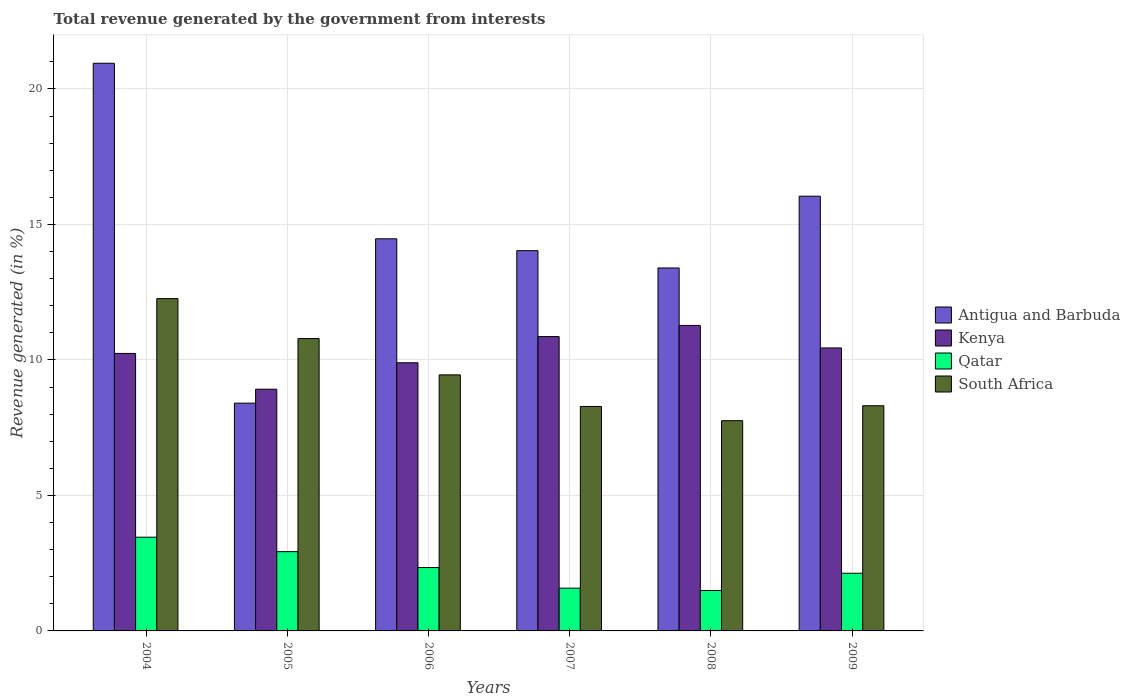What is the label of the 3rd group of bars from the left?
Your answer should be very brief. 2006. What is the total revenue generated in South Africa in 2006?
Your answer should be compact. 9.45. Across all years, what is the maximum total revenue generated in Qatar?
Your response must be concise. 3.46. Across all years, what is the minimum total revenue generated in Antigua and Barbuda?
Provide a succinct answer. 8.41. What is the total total revenue generated in Qatar in the graph?
Give a very brief answer. 13.92. What is the difference between the total revenue generated in Antigua and Barbuda in 2006 and that in 2008?
Your answer should be compact. 1.08. What is the difference between the total revenue generated in Antigua and Barbuda in 2008 and the total revenue generated in South Africa in 2009?
Your answer should be compact. 5.08. What is the average total revenue generated in Antigua and Barbuda per year?
Ensure brevity in your answer.  14.55. In the year 2005, what is the difference between the total revenue generated in Kenya and total revenue generated in South Africa?
Provide a short and direct response. -1.87. What is the ratio of the total revenue generated in Kenya in 2004 to that in 2006?
Ensure brevity in your answer.  1.03. Is the total revenue generated in Kenya in 2006 less than that in 2009?
Provide a succinct answer. Yes. What is the difference between the highest and the second highest total revenue generated in South Africa?
Your answer should be compact. 1.47. What is the difference between the highest and the lowest total revenue generated in Antigua and Barbuda?
Your response must be concise. 12.54. Is the sum of the total revenue generated in South Africa in 2006 and 2009 greater than the maximum total revenue generated in Kenya across all years?
Ensure brevity in your answer.  Yes. What does the 1st bar from the left in 2004 represents?
Your response must be concise. Antigua and Barbuda. What does the 2nd bar from the right in 2007 represents?
Your answer should be very brief. Qatar. Is it the case that in every year, the sum of the total revenue generated in Qatar and total revenue generated in Antigua and Barbuda is greater than the total revenue generated in South Africa?
Your response must be concise. Yes. How many years are there in the graph?
Offer a terse response. 6. What is the difference between two consecutive major ticks on the Y-axis?
Your answer should be compact. 5. Does the graph contain grids?
Your response must be concise. Yes. What is the title of the graph?
Ensure brevity in your answer.  Total revenue generated by the government from interests. Does "Rwanda" appear as one of the legend labels in the graph?
Keep it short and to the point. No. What is the label or title of the Y-axis?
Offer a very short reply. Revenue generated (in %). What is the Revenue generated (in %) in Antigua and Barbuda in 2004?
Your answer should be very brief. 20.95. What is the Revenue generated (in %) in Kenya in 2004?
Offer a very short reply. 10.24. What is the Revenue generated (in %) in Qatar in 2004?
Offer a very short reply. 3.46. What is the Revenue generated (in %) of South Africa in 2004?
Give a very brief answer. 12.26. What is the Revenue generated (in %) in Antigua and Barbuda in 2005?
Give a very brief answer. 8.41. What is the Revenue generated (in %) of Kenya in 2005?
Your answer should be very brief. 8.92. What is the Revenue generated (in %) in Qatar in 2005?
Give a very brief answer. 2.92. What is the Revenue generated (in %) in South Africa in 2005?
Provide a succinct answer. 10.79. What is the Revenue generated (in %) in Antigua and Barbuda in 2006?
Ensure brevity in your answer.  14.47. What is the Revenue generated (in %) of Kenya in 2006?
Offer a terse response. 9.9. What is the Revenue generated (in %) in Qatar in 2006?
Provide a short and direct response. 2.34. What is the Revenue generated (in %) of South Africa in 2006?
Provide a short and direct response. 9.45. What is the Revenue generated (in %) in Antigua and Barbuda in 2007?
Provide a succinct answer. 14.03. What is the Revenue generated (in %) in Kenya in 2007?
Your answer should be compact. 10.86. What is the Revenue generated (in %) of Qatar in 2007?
Make the answer very short. 1.58. What is the Revenue generated (in %) of South Africa in 2007?
Keep it short and to the point. 8.28. What is the Revenue generated (in %) in Antigua and Barbuda in 2008?
Provide a succinct answer. 13.39. What is the Revenue generated (in %) of Kenya in 2008?
Offer a terse response. 11.27. What is the Revenue generated (in %) of Qatar in 2008?
Keep it short and to the point. 1.49. What is the Revenue generated (in %) in South Africa in 2008?
Give a very brief answer. 7.76. What is the Revenue generated (in %) in Antigua and Barbuda in 2009?
Offer a very short reply. 16.04. What is the Revenue generated (in %) of Kenya in 2009?
Your answer should be compact. 10.44. What is the Revenue generated (in %) in Qatar in 2009?
Provide a short and direct response. 2.13. What is the Revenue generated (in %) in South Africa in 2009?
Offer a very short reply. 8.31. Across all years, what is the maximum Revenue generated (in %) in Antigua and Barbuda?
Your answer should be compact. 20.95. Across all years, what is the maximum Revenue generated (in %) of Kenya?
Provide a succinct answer. 11.27. Across all years, what is the maximum Revenue generated (in %) of Qatar?
Offer a very short reply. 3.46. Across all years, what is the maximum Revenue generated (in %) of South Africa?
Make the answer very short. 12.26. Across all years, what is the minimum Revenue generated (in %) of Antigua and Barbuda?
Your answer should be very brief. 8.41. Across all years, what is the minimum Revenue generated (in %) in Kenya?
Your answer should be compact. 8.92. Across all years, what is the minimum Revenue generated (in %) of Qatar?
Ensure brevity in your answer.  1.49. Across all years, what is the minimum Revenue generated (in %) in South Africa?
Your answer should be compact. 7.76. What is the total Revenue generated (in %) of Antigua and Barbuda in the graph?
Your answer should be very brief. 87.29. What is the total Revenue generated (in %) in Kenya in the graph?
Ensure brevity in your answer.  61.63. What is the total Revenue generated (in %) of Qatar in the graph?
Offer a very short reply. 13.92. What is the total Revenue generated (in %) in South Africa in the graph?
Offer a very short reply. 56.85. What is the difference between the Revenue generated (in %) of Antigua and Barbuda in 2004 and that in 2005?
Offer a very short reply. 12.54. What is the difference between the Revenue generated (in %) in Kenya in 2004 and that in 2005?
Offer a very short reply. 1.32. What is the difference between the Revenue generated (in %) in Qatar in 2004 and that in 2005?
Offer a terse response. 0.53. What is the difference between the Revenue generated (in %) of South Africa in 2004 and that in 2005?
Ensure brevity in your answer.  1.47. What is the difference between the Revenue generated (in %) in Antigua and Barbuda in 2004 and that in 2006?
Make the answer very short. 6.48. What is the difference between the Revenue generated (in %) in Kenya in 2004 and that in 2006?
Keep it short and to the point. 0.34. What is the difference between the Revenue generated (in %) of Qatar in 2004 and that in 2006?
Your answer should be compact. 1.12. What is the difference between the Revenue generated (in %) in South Africa in 2004 and that in 2006?
Your response must be concise. 2.81. What is the difference between the Revenue generated (in %) in Antigua and Barbuda in 2004 and that in 2007?
Keep it short and to the point. 6.92. What is the difference between the Revenue generated (in %) in Kenya in 2004 and that in 2007?
Keep it short and to the point. -0.62. What is the difference between the Revenue generated (in %) of Qatar in 2004 and that in 2007?
Provide a short and direct response. 1.88. What is the difference between the Revenue generated (in %) of South Africa in 2004 and that in 2007?
Your response must be concise. 3.98. What is the difference between the Revenue generated (in %) in Antigua and Barbuda in 2004 and that in 2008?
Keep it short and to the point. 7.55. What is the difference between the Revenue generated (in %) of Kenya in 2004 and that in 2008?
Offer a very short reply. -1.03. What is the difference between the Revenue generated (in %) of Qatar in 2004 and that in 2008?
Your answer should be very brief. 1.97. What is the difference between the Revenue generated (in %) of South Africa in 2004 and that in 2008?
Your response must be concise. 4.51. What is the difference between the Revenue generated (in %) in Antigua and Barbuda in 2004 and that in 2009?
Keep it short and to the point. 4.91. What is the difference between the Revenue generated (in %) of Kenya in 2004 and that in 2009?
Make the answer very short. -0.2. What is the difference between the Revenue generated (in %) in Qatar in 2004 and that in 2009?
Provide a short and direct response. 1.33. What is the difference between the Revenue generated (in %) in South Africa in 2004 and that in 2009?
Give a very brief answer. 3.95. What is the difference between the Revenue generated (in %) of Antigua and Barbuda in 2005 and that in 2006?
Offer a very short reply. -6.07. What is the difference between the Revenue generated (in %) in Kenya in 2005 and that in 2006?
Offer a very short reply. -0.98. What is the difference between the Revenue generated (in %) in Qatar in 2005 and that in 2006?
Offer a terse response. 0.59. What is the difference between the Revenue generated (in %) of South Africa in 2005 and that in 2006?
Ensure brevity in your answer.  1.34. What is the difference between the Revenue generated (in %) of Antigua and Barbuda in 2005 and that in 2007?
Your answer should be very brief. -5.63. What is the difference between the Revenue generated (in %) of Kenya in 2005 and that in 2007?
Provide a short and direct response. -1.94. What is the difference between the Revenue generated (in %) of Qatar in 2005 and that in 2007?
Ensure brevity in your answer.  1.35. What is the difference between the Revenue generated (in %) in South Africa in 2005 and that in 2007?
Your answer should be compact. 2.51. What is the difference between the Revenue generated (in %) of Antigua and Barbuda in 2005 and that in 2008?
Provide a short and direct response. -4.99. What is the difference between the Revenue generated (in %) in Kenya in 2005 and that in 2008?
Make the answer very short. -2.35. What is the difference between the Revenue generated (in %) in Qatar in 2005 and that in 2008?
Your response must be concise. 1.43. What is the difference between the Revenue generated (in %) of South Africa in 2005 and that in 2008?
Ensure brevity in your answer.  3.03. What is the difference between the Revenue generated (in %) in Antigua and Barbuda in 2005 and that in 2009?
Provide a short and direct response. -7.64. What is the difference between the Revenue generated (in %) in Kenya in 2005 and that in 2009?
Provide a succinct answer. -1.52. What is the difference between the Revenue generated (in %) of Qatar in 2005 and that in 2009?
Make the answer very short. 0.8. What is the difference between the Revenue generated (in %) in South Africa in 2005 and that in 2009?
Provide a short and direct response. 2.48. What is the difference between the Revenue generated (in %) in Antigua and Barbuda in 2006 and that in 2007?
Offer a very short reply. 0.44. What is the difference between the Revenue generated (in %) in Kenya in 2006 and that in 2007?
Give a very brief answer. -0.97. What is the difference between the Revenue generated (in %) of Qatar in 2006 and that in 2007?
Offer a very short reply. 0.76. What is the difference between the Revenue generated (in %) of South Africa in 2006 and that in 2007?
Your answer should be very brief. 1.17. What is the difference between the Revenue generated (in %) in Kenya in 2006 and that in 2008?
Provide a succinct answer. -1.38. What is the difference between the Revenue generated (in %) of Qatar in 2006 and that in 2008?
Provide a short and direct response. 0.85. What is the difference between the Revenue generated (in %) of South Africa in 2006 and that in 2008?
Keep it short and to the point. 1.69. What is the difference between the Revenue generated (in %) of Antigua and Barbuda in 2006 and that in 2009?
Your response must be concise. -1.57. What is the difference between the Revenue generated (in %) of Kenya in 2006 and that in 2009?
Provide a short and direct response. -0.55. What is the difference between the Revenue generated (in %) of Qatar in 2006 and that in 2009?
Ensure brevity in your answer.  0.21. What is the difference between the Revenue generated (in %) in South Africa in 2006 and that in 2009?
Your answer should be very brief. 1.14. What is the difference between the Revenue generated (in %) of Antigua and Barbuda in 2007 and that in 2008?
Make the answer very short. 0.64. What is the difference between the Revenue generated (in %) in Kenya in 2007 and that in 2008?
Give a very brief answer. -0.41. What is the difference between the Revenue generated (in %) in Qatar in 2007 and that in 2008?
Make the answer very short. 0.09. What is the difference between the Revenue generated (in %) in South Africa in 2007 and that in 2008?
Your response must be concise. 0.52. What is the difference between the Revenue generated (in %) in Antigua and Barbuda in 2007 and that in 2009?
Provide a short and direct response. -2.01. What is the difference between the Revenue generated (in %) of Kenya in 2007 and that in 2009?
Make the answer very short. 0.42. What is the difference between the Revenue generated (in %) in Qatar in 2007 and that in 2009?
Keep it short and to the point. -0.55. What is the difference between the Revenue generated (in %) of South Africa in 2007 and that in 2009?
Your response must be concise. -0.03. What is the difference between the Revenue generated (in %) in Antigua and Barbuda in 2008 and that in 2009?
Give a very brief answer. -2.65. What is the difference between the Revenue generated (in %) in Kenya in 2008 and that in 2009?
Give a very brief answer. 0.83. What is the difference between the Revenue generated (in %) of Qatar in 2008 and that in 2009?
Your response must be concise. -0.64. What is the difference between the Revenue generated (in %) in South Africa in 2008 and that in 2009?
Provide a succinct answer. -0.55. What is the difference between the Revenue generated (in %) in Antigua and Barbuda in 2004 and the Revenue generated (in %) in Kenya in 2005?
Your response must be concise. 12.03. What is the difference between the Revenue generated (in %) of Antigua and Barbuda in 2004 and the Revenue generated (in %) of Qatar in 2005?
Ensure brevity in your answer.  18.02. What is the difference between the Revenue generated (in %) in Antigua and Barbuda in 2004 and the Revenue generated (in %) in South Africa in 2005?
Provide a short and direct response. 10.16. What is the difference between the Revenue generated (in %) in Kenya in 2004 and the Revenue generated (in %) in Qatar in 2005?
Provide a short and direct response. 7.32. What is the difference between the Revenue generated (in %) of Kenya in 2004 and the Revenue generated (in %) of South Africa in 2005?
Provide a succinct answer. -0.55. What is the difference between the Revenue generated (in %) of Qatar in 2004 and the Revenue generated (in %) of South Africa in 2005?
Ensure brevity in your answer.  -7.33. What is the difference between the Revenue generated (in %) in Antigua and Barbuda in 2004 and the Revenue generated (in %) in Kenya in 2006?
Offer a terse response. 11.05. What is the difference between the Revenue generated (in %) of Antigua and Barbuda in 2004 and the Revenue generated (in %) of Qatar in 2006?
Offer a very short reply. 18.61. What is the difference between the Revenue generated (in %) of Antigua and Barbuda in 2004 and the Revenue generated (in %) of South Africa in 2006?
Your answer should be very brief. 11.5. What is the difference between the Revenue generated (in %) in Kenya in 2004 and the Revenue generated (in %) in Qatar in 2006?
Provide a short and direct response. 7.9. What is the difference between the Revenue generated (in %) in Kenya in 2004 and the Revenue generated (in %) in South Africa in 2006?
Provide a short and direct response. 0.79. What is the difference between the Revenue generated (in %) of Qatar in 2004 and the Revenue generated (in %) of South Africa in 2006?
Your answer should be compact. -5.99. What is the difference between the Revenue generated (in %) of Antigua and Barbuda in 2004 and the Revenue generated (in %) of Kenya in 2007?
Your answer should be compact. 10.09. What is the difference between the Revenue generated (in %) of Antigua and Barbuda in 2004 and the Revenue generated (in %) of Qatar in 2007?
Provide a short and direct response. 19.37. What is the difference between the Revenue generated (in %) in Antigua and Barbuda in 2004 and the Revenue generated (in %) in South Africa in 2007?
Keep it short and to the point. 12.67. What is the difference between the Revenue generated (in %) of Kenya in 2004 and the Revenue generated (in %) of Qatar in 2007?
Provide a short and direct response. 8.66. What is the difference between the Revenue generated (in %) in Kenya in 2004 and the Revenue generated (in %) in South Africa in 2007?
Make the answer very short. 1.96. What is the difference between the Revenue generated (in %) of Qatar in 2004 and the Revenue generated (in %) of South Africa in 2007?
Your answer should be compact. -4.82. What is the difference between the Revenue generated (in %) of Antigua and Barbuda in 2004 and the Revenue generated (in %) of Kenya in 2008?
Give a very brief answer. 9.67. What is the difference between the Revenue generated (in %) of Antigua and Barbuda in 2004 and the Revenue generated (in %) of Qatar in 2008?
Provide a succinct answer. 19.46. What is the difference between the Revenue generated (in %) in Antigua and Barbuda in 2004 and the Revenue generated (in %) in South Africa in 2008?
Offer a terse response. 13.19. What is the difference between the Revenue generated (in %) in Kenya in 2004 and the Revenue generated (in %) in Qatar in 2008?
Make the answer very short. 8.75. What is the difference between the Revenue generated (in %) in Kenya in 2004 and the Revenue generated (in %) in South Africa in 2008?
Offer a terse response. 2.48. What is the difference between the Revenue generated (in %) in Qatar in 2004 and the Revenue generated (in %) in South Africa in 2008?
Offer a terse response. -4.3. What is the difference between the Revenue generated (in %) of Antigua and Barbuda in 2004 and the Revenue generated (in %) of Kenya in 2009?
Your response must be concise. 10.51. What is the difference between the Revenue generated (in %) in Antigua and Barbuda in 2004 and the Revenue generated (in %) in Qatar in 2009?
Provide a succinct answer. 18.82. What is the difference between the Revenue generated (in %) of Antigua and Barbuda in 2004 and the Revenue generated (in %) of South Africa in 2009?
Make the answer very short. 12.64. What is the difference between the Revenue generated (in %) of Kenya in 2004 and the Revenue generated (in %) of Qatar in 2009?
Make the answer very short. 8.11. What is the difference between the Revenue generated (in %) in Kenya in 2004 and the Revenue generated (in %) in South Africa in 2009?
Offer a terse response. 1.93. What is the difference between the Revenue generated (in %) in Qatar in 2004 and the Revenue generated (in %) in South Africa in 2009?
Provide a succinct answer. -4.85. What is the difference between the Revenue generated (in %) in Antigua and Barbuda in 2005 and the Revenue generated (in %) in Kenya in 2006?
Provide a short and direct response. -1.49. What is the difference between the Revenue generated (in %) in Antigua and Barbuda in 2005 and the Revenue generated (in %) in Qatar in 2006?
Offer a very short reply. 6.07. What is the difference between the Revenue generated (in %) of Antigua and Barbuda in 2005 and the Revenue generated (in %) of South Africa in 2006?
Give a very brief answer. -1.04. What is the difference between the Revenue generated (in %) of Kenya in 2005 and the Revenue generated (in %) of Qatar in 2006?
Your response must be concise. 6.58. What is the difference between the Revenue generated (in %) in Kenya in 2005 and the Revenue generated (in %) in South Africa in 2006?
Provide a succinct answer. -0.53. What is the difference between the Revenue generated (in %) in Qatar in 2005 and the Revenue generated (in %) in South Africa in 2006?
Offer a terse response. -6.52. What is the difference between the Revenue generated (in %) in Antigua and Barbuda in 2005 and the Revenue generated (in %) in Kenya in 2007?
Provide a short and direct response. -2.46. What is the difference between the Revenue generated (in %) of Antigua and Barbuda in 2005 and the Revenue generated (in %) of Qatar in 2007?
Provide a succinct answer. 6.83. What is the difference between the Revenue generated (in %) of Antigua and Barbuda in 2005 and the Revenue generated (in %) of South Africa in 2007?
Provide a short and direct response. 0.12. What is the difference between the Revenue generated (in %) in Kenya in 2005 and the Revenue generated (in %) in Qatar in 2007?
Offer a very short reply. 7.34. What is the difference between the Revenue generated (in %) of Kenya in 2005 and the Revenue generated (in %) of South Africa in 2007?
Keep it short and to the point. 0.64. What is the difference between the Revenue generated (in %) in Qatar in 2005 and the Revenue generated (in %) in South Africa in 2007?
Provide a succinct answer. -5.36. What is the difference between the Revenue generated (in %) of Antigua and Barbuda in 2005 and the Revenue generated (in %) of Kenya in 2008?
Offer a very short reply. -2.87. What is the difference between the Revenue generated (in %) in Antigua and Barbuda in 2005 and the Revenue generated (in %) in Qatar in 2008?
Provide a succinct answer. 6.91. What is the difference between the Revenue generated (in %) in Antigua and Barbuda in 2005 and the Revenue generated (in %) in South Africa in 2008?
Your answer should be compact. 0.65. What is the difference between the Revenue generated (in %) of Kenya in 2005 and the Revenue generated (in %) of Qatar in 2008?
Keep it short and to the point. 7.43. What is the difference between the Revenue generated (in %) of Kenya in 2005 and the Revenue generated (in %) of South Africa in 2008?
Offer a terse response. 1.16. What is the difference between the Revenue generated (in %) in Qatar in 2005 and the Revenue generated (in %) in South Africa in 2008?
Ensure brevity in your answer.  -4.83. What is the difference between the Revenue generated (in %) of Antigua and Barbuda in 2005 and the Revenue generated (in %) of Kenya in 2009?
Give a very brief answer. -2.04. What is the difference between the Revenue generated (in %) of Antigua and Barbuda in 2005 and the Revenue generated (in %) of Qatar in 2009?
Offer a very short reply. 6.28. What is the difference between the Revenue generated (in %) in Antigua and Barbuda in 2005 and the Revenue generated (in %) in South Africa in 2009?
Make the answer very short. 0.1. What is the difference between the Revenue generated (in %) of Kenya in 2005 and the Revenue generated (in %) of Qatar in 2009?
Your answer should be very brief. 6.79. What is the difference between the Revenue generated (in %) of Kenya in 2005 and the Revenue generated (in %) of South Africa in 2009?
Keep it short and to the point. 0.61. What is the difference between the Revenue generated (in %) of Qatar in 2005 and the Revenue generated (in %) of South Africa in 2009?
Offer a very short reply. -5.38. What is the difference between the Revenue generated (in %) in Antigua and Barbuda in 2006 and the Revenue generated (in %) in Kenya in 2007?
Keep it short and to the point. 3.61. What is the difference between the Revenue generated (in %) of Antigua and Barbuda in 2006 and the Revenue generated (in %) of Qatar in 2007?
Your response must be concise. 12.89. What is the difference between the Revenue generated (in %) in Antigua and Barbuda in 2006 and the Revenue generated (in %) in South Africa in 2007?
Ensure brevity in your answer.  6.19. What is the difference between the Revenue generated (in %) in Kenya in 2006 and the Revenue generated (in %) in Qatar in 2007?
Keep it short and to the point. 8.32. What is the difference between the Revenue generated (in %) of Kenya in 2006 and the Revenue generated (in %) of South Africa in 2007?
Your answer should be compact. 1.61. What is the difference between the Revenue generated (in %) in Qatar in 2006 and the Revenue generated (in %) in South Africa in 2007?
Keep it short and to the point. -5.94. What is the difference between the Revenue generated (in %) in Antigua and Barbuda in 2006 and the Revenue generated (in %) in Kenya in 2008?
Provide a succinct answer. 3.2. What is the difference between the Revenue generated (in %) in Antigua and Barbuda in 2006 and the Revenue generated (in %) in Qatar in 2008?
Keep it short and to the point. 12.98. What is the difference between the Revenue generated (in %) in Antigua and Barbuda in 2006 and the Revenue generated (in %) in South Africa in 2008?
Offer a terse response. 6.71. What is the difference between the Revenue generated (in %) in Kenya in 2006 and the Revenue generated (in %) in Qatar in 2008?
Your response must be concise. 8.4. What is the difference between the Revenue generated (in %) in Kenya in 2006 and the Revenue generated (in %) in South Africa in 2008?
Your answer should be compact. 2.14. What is the difference between the Revenue generated (in %) of Qatar in 2006 and the Revenue generated (in %) of South Africa in 2008?
Offer a terse response. -5.42. What is the difference between the Revenue generated (in %) in Antigua and Barbuda in 2006 and the Revenue generated (in %) in Kenya in 2009?
Keep it short and to the point. 4.03. What is the difference between the Revenue generated (in %) in Antigua and Barbuda in 2006 and the Revenue generated (in %) in Qatar in 2009?
Offer a terse response. 12.34. What is the difference between the Revenue generated (in %) of Antigua and Barbuda in 2006 and the Revenue generated (in %) of South Africa in 2009?
Your answer should be very brief. 6.16. What is the difference between the Revenue generated (in %) in Kenya in 2006 and the Revenue generated (in %) in Qatar in 2009?
Offer a very short reply. 7.77. What is the difference between the Revenue generated (in %) in Kenya in 2006 and the Revenue generated (in %) in South Africa in 2009?
Keep it short and to the point. 1.59. What is the difference between the Revenue generated (in %) of Qatar in 2006 and the Revenue generated (in %) of South Africa in 2009?
Give a very brief answer. -5.97. What is the difference between the Revenue generated (in %) of Antigua and Barbuda in 2007 and the Revenue generated (in %) of Kenya in 2008?
Provide a succinct answer. 2.76. What is the difference between the Revenue generated (in %) of Antigua and Barbuda in 2007 and the Revenue generated (in %) of Qatar in 2008?
Provide a short and direct response. 12.54. What is the difference between the Revenue generated (in %) of Antigua and Barbuda in 2007 and the Revenue generated (in %) of South Africa in 2008?
Your answer should be very brief. 6.27. What is the difference between the Revenue generated (in %) of Kenya in 2007 and the Revenue generated (in %) of Qatar in 2008?
Ensure brevity in your answer.  9.37. What is the difference between the Revenue generated (in %) in Kenya in 2007 and the Revenue generated (in %) in South Africa in 2008?
Make the answer very short. 3.1. What is the difference between the Revenue generated (in %) in Qatar in 2007 and the Revenue generated (in %) in South Africa in 2008?
Your answer should be very brief. -6.18. What is the difference between the Revenue generated (in %) in Antigua and Barbuda in 2007 and the Revenue generated (in %) in Kenya in 2009?
Make the answer very short. 3.59. What is the difference between the Revenue generated (in %) in Antigua and Barbuda in 2007 and the Revenue generated (in %) in Qatar in 2009?
Your answer should be compact. 11.9. What is the difference between the Revenue generated (in %) of Antigua and Barbuda in 2007 and the Revenue generated (in %) of South Africa in 2009?
Your response must be concise. 5.72. What is the difference between the Revenue generated (in %) of Kenya in 2007 and the Revenue generated (in %) of Qatar in 2009?
Offer a terse response. 8.73. What is the difference between the Revenue generated (in %) in Kenya in 2007 and the Revenue generated (in %) in South Africa in 2009?
Make the answer very short. 2.55. What is the difference between the Revenue generated (in %) of Qatar in 2007 and the Revenue generated (in %) of South Africa in 2009?
Your answer should be very brief. -6.73. What is the difference between the Revenue generated (in %) of Antigua and Barbuda in 2008 and the Revenue generated (in %) of Kenya in 2009?
Ensure brevity in your answer.  2.95. What is the difference between the Revenue generated (in %) of Antigua and Barbuda in 2008 and the Revenue generated (in %) of Qatar in 2009?
Offer a terse response. 11.27. What is the difference between the Revenue generated (in %) of Antigua and Barbuda in 2008 and the Revenue generated (in %) of South Africa in 2009?
Offer a very short reply. 5.08. What is the difference between the Revenue generated (in %) of Kenya in 2008 and the Revenue generated (in %) of Qatar in 2009?
Your response must be concise. 9.15. What is the difference between the Revenue generated (in %) in Kenya in 2008 and the Revenue generated (in %) in South Africa in 2009?
Your answer should be very brief. 2.96. What is the difference between the Revenue generated (in %) in Qatar in 2008 and the Revenue generated (in %) in South Africa in 2009?
Your answer should be very brief. -6.82. What is the average Revenue generated (in %) in Antigua and Barbuda per year?
Make the answer very short. 14.55. What is the average Revenue generated (in %) in Kenya per year?
Offer a terse response. 10.27. What is the average Revenue generated (in %) in Qatar per year?
Ensure brevity in your answer.  2.32. What is the average Revenue generated (in %) in South Africa per year?
Ensure brevity in your answer.  9.48. In the year 2004, what is the difference between the Revenue generated (in %) of Antigua and Barbuda and Revenue generated (in %) of Kenya?
Keep it short and to the point. 10.71. In the year 2004, what is the difference between the Revenue generated (in %) in Antigua and Barbuda and Revenue generated (in %) in Qatar?
Offer a very short reply. 17.49. In the year 2004, what is the difference between the Revenue generated (in %) of Antigua and Barbuda and Revenue generated (in %) of South Africa?
Provide a succinct answer. 8.69. In the year 2004, what is the difference between the Revenue generated (in %) of Kenya and Revenue generated (in %) of Qatar?
Provide a succinct answer. 6.78. In the year 2004, what is the difference between the Revenue generated (in %) of Kenya and Revenue generated (in %) of South Africa?
Give a very brief answer. -2.02. In the year 2004, what is the difference between the Revenue generated (in %) of Qatar and Revenue generated (in %) of South Africa?
Provide a succinct answer. -8.8. In the year 2005, what is the difference between the Revenue generated (in %) in Antigua and Barbuda and Revenue generated (in %) in Kenya?
Offer a terse response. -0.51. In the year 2005, what is the difference between the Revenue generated (in %) in Antigua and Barbuda and Revenue generated (in %) in Qatar?
Keep it short and to the point. 5.48. In the year 2005, what is the difference between the Revenue generated (in %) of Antigua and Barbuda and Revenue generated (in %) of South Africa?
Ensure brevity in your answer.  -2.38. In the year 2005, what is the difference between the Revenue generated (in %) of Kenya and Revenue generated (in %) of Qatar?
Provide a succinct answer. 6. In the year 2005, what is the difference between the Revenue generated (in %) of Kenya and Revenue generated (in %) of South Africa?
Give a very brief answer. -1.87. In the year 2005, what is the difference between the Revenue generated (in %) of Qatar and Revenue generated (in %) of South Africa?
Offer a very short reply. -7.86. In the year 2006, what is the difference between the Revenue generated (in %) in Antigua and Barbuda and Revenue generated (in %) in Kenya?
Give a very brief answer. 4.58. In the year 2006, what is the difference between the Revenue generated (in %) of Antigua and Barbuda and Revenue generated (in %) of Qatar?
Make the answer very short. 12.13. In the year 2006, what is the difference between the Revenue generated (in %) of Antigua and Barbuda and Revenue generated (in %) of South Africa?
Provide a short and direct response. 5.02. In the year 2006, what is the difference between the Revenue generated (in %) in Kenya and Revenue generated (in %) in Qatar?
Offer a terse response. 7.56. In the year 2006, what is the difference between the Revenue generated (in %) in Kenya and Revenue generated (in %) in South Africa?
Your answer should be compact. 0.45. In the year 2006, what is the difference between the Revenue generated (in %) in Qatar and Revenue generated (in %) in South Africa?
Your response must be concise. -7.11. In the year 2007, what is the difference between the Revenue generated (in %) of Antigua and Barbuda and Revenue generated (in %) of Kenya?
Provide a succinct answer. 3.17. In the year 2007, what is the difference between the Revenue generated (in %) in Antigua and Barbuda and Revenue generated (in %) in Qatar?
Provide a short and direct response. 12.45. In the year 2007, what is the difference between the Revenue generated (in %) of Antigua and Barbuda and Revenue generated (in %) of South Africa?
Provide a short and direct response. 5.75. In the year 2007, what is the difference between the Revenue generated (in %) of Kenya and Revenue generated (in %) of Qatar?
Keep it short and to the point. 9.28. In the year 2007, what is the difference between the Revenue generated (in %) in Kenya and Revenue generated (in %) in South Africa?
Make the answer very short. 2.58. In the year 2007, what is the difference between the Revenue generated (in %) in Qatar and Revenue generated (in %) in South Africa?
Give a very brief answer. -6.7. In the year 2008, what is the difference between the Revenue generated (in %) of Antigua and Barbuda and Revenue generated (in %) of Kenya?
Make the answer very short. 2.12. In the year 2008, what is the difference between the Revenue generated (in %) in Antigua and Barbuda and Revenue generated (in %) in Qatar?
Ensure brevity in your answer.  11.9. In the year 2008, what is the difference between the Revenue generated (in %) in Antigua and Barbuda and Revenue generated (in %) in South Africa?
Your response must be concise. 5.64. In the year 2008, what is the difference between the Revenue generated (in %) in Kenya and Revenue generated (in %) in Qatar?
Provide a succinct answer. 9.78. In the year 2008, what is the difference between the Revenue generated (in %) in Kenya and Revenue generated (in %) in South Africa?
Your answer should be very brief. 3.52. In the year 2008, what is the difference between the Revenue generated (in %) in Qatar and Revenue generated (in %) in South Africa?
Your response must be concise. -6.27. In the year 2009, what is the difference between the Revenue generated (in %) in Antigua and Barbuda and Revenue generated (in %) in Kenya?
Offer a very short reply. 5.6. In the year 2009, what is the difference between the Revenue generated (in %) in Antigua and Barbuda and Revenue generated (in %) in Qatar?
Make the answer very short. 13.91. In the year 2009, what is the difference between the Revenue generated (in %) of Antigua and Barbuda and Revenue generated (in %) of South Africa?
Keep it short and to the point. 7.73. In the year 2009, what is the difference between the Revenue generated (in %) of Kenya and Revenue generated (in %) of Qatar?
Keep it short and to the point. 8.31. In the year 2009, what is the difference between the Revenue generated (in %) in Kenya and Revenue generated (in %) in South Africa?
Provide a short and direct response. 2.13. In the year 2009, what is the difference between the Revenue generated (in %) in Qatar and Revenue generated (in %) in South Africa?
Give a very brief answer. -6.18. What is the ratio of the Revenue generated (in %) of Antigua and Barbuda in 2004 to that in 2005?
Provide a short and direct response. 2.49. What is the ratio of the Revenue generated (in %) of Kenya in 2004 to that in 2005?
Make the answer very short. 1.15. What is the ratio of the Revenue generated (in %) in Qatar in 2004 to that in 2005?
Provide a succinct answer. 1.18. What is the ratio of the Revenue generated (in %) in South Africa in 2004 to that in 2005?
Ensure brevity in your answer.  1.14. What is the ratio of the Revenue generated (in %) in Antigua and Barbuda in 2004 to that in 2006?
Your response must be concise. 1.45. What is the ratio of the Revenue generated (in %) in Kenya in 2004 to that in 2006?
Provide a succinct answer. 1.03. What is the ratio of the Revenue generated (in %) in Qatar in 2004 to that in 2006?
Provide a succinct answer. 1.48. What is the ratio of the Revenue generated (in %) in South Africa in 2004 to that in 2006?
Make the answer very short. 1.3. What is the ratio of the Revenue generated (in %) in Antigua and Barbuda in 2004 to that in 2007?
Keep it short and to the point. 1.49. What is the ratio of the Revenue generated (in %) in Kenya in 2004 to that in 2007?
Offer a terse response. 0.94. What is the ratio of the Revenue generated (in %) in Qatar in 2004 to that in 2007?
Provide a short and direct response. 2.19. What is the ratio of the Revenue generated (in %) in South Africa in 2004 to that in 2007?
Provide a succinct answer. 1.48. What is the ratio of the Revenue generated (in %) of Antigua and Barbuda in 2004 to that in 2008?
Ensure brevity in your answer.  1.56. What is the ratio of the Revenue generated (in %) of Kenya in 2004 to that in 2008?
Offer a very short reply. 0.91. What is the ratio of the Revenue generated (in %) in Qatar in 2004 to that in 2008?
Offer a terse response. 2.32. What is the ratio of the Revenue generated (in %) in South Africa in 2004 to that in 2008?
Your answer should be very brief. 1.58. What is the ratio of the Revenue generated (in %) of Antigua and Barbuda in 2004 to that in 2009?
Ensure brevity in your answer.  1.31. What is the ratio of the Revenue generated (in %) in Kenya in 2004 to that in 2009?
Offer a terse response. 0.98. What is the ratio of the Revenue generated (in %) of Qatar in 2004 to that in 2009?
Provide a succinct answer. 1.62. What is the ratio of the Revenue generated (in %) in South Africa in 2004 to that in 2009?
Keep it short and to the point. 1.48. What is the ratio of the Revenue generated (in %) in Antigua and Barbuda in 2005 to that in 2006?
Keep it short and to the point. 0.58. What is the ratio of the Revenue generated (in %) of Kenya in 2005 to that in 2006?
Your answer should be very brief. 0.9. What is the ratio of the Revenue generated (in %) of Qatar in 2005 to that in 2006?
Keep it short and to the point. 1.25. What is the ratio of the Revenue generated (in %) in South Africa in 2005 to that in 2006?
Offer a very short reply. 1.14. What is the ratio of the Revenue generated (in %) of Antigua and Barbuda in 2005 to that in 2007?
Provide a short and direct response. 0.6. What is the ratio of the Revenue generated (in %) of Kenya in 2005 to that in 2007?
Your answer should be very brief. 0.82. What is the ratio of the Revenue generated (in %) in Qatar in 2005 to that in 2007?
Keep it short and to the point. 1.85. What is the ratio of the Revenue generated (in %) in South Africa in 2005 to that in 2007?
Make the answer very short. 1.3. What is the ratio of the Revenue generated (in %) of Antigua and Barbuda in 2005 to that in 2008?
Your response must be concise. 0.63. What is the ratio of the Revenue generated (in %) of Kenya in 2005 to that in 2008?
Offer a very short reply. 0.79. What is the ratio of the Revenue generated (in %) of Qatar in 2005 to that in 2008?
Offer a very short reply. 1.96. What is the ratio of the Revenue generated (in %) in South Africa in 2005 to that in 2008?
Give a very brief answer. 1.39. What is the ratio of the Revenue generated (in %) in Antigua and Barbuda in 2005 to that in 2009?
Offer a very short reply. 0.52. What is the ratio of the Revenue generated (in %) of Kenya in 2005 to that in 2009?
Your answer should be compact. 0.85. What is the ratio of the Revenue generated (in %) in Qatar in 2005 to that in 2009?
Your answer should be very brief. 1.37. What is the ratio of the Revenue generated (in %) of South Africa in 2005 to that in 2009?
Offer a terse response. 1.3. What is the ratio of the Revenue generated (in %) of Antigua and Barbuda in 2006 to that in 2007?
Give a very brief answer. 1.03. What is the ratio of the Revenue generated (in %) in Kenya in 2006 to that in 2007?
Your response must be concise. 0.91. What is the ratio of the Revenue generated (in %) in Qatar in 2006 to that in 2007?
Provide a short and direct response. 1.48. What is the ratio of the Revenue generated (in %) in South Africa in 2006 to that in 2007?
Give a very brief answer. 1.14. What is the ratio of the Revenue generated (in %) of Antigua and Barbuda in 2006 to that in 2008?
Make the answer very short. 1.08. What is the ratio of the Revenue generated (in %) of Kenya in 2006 to that in 2008?
Your answer should be very brief. 0.88. What is the ratio of the Revenue generated (in %) of Qatar in 2006 to that in 2008?
Your answer should be very brief. 1.57. What is the ratio of the Revenue generated (in %) in South Africa in 2006 to that in 2008?
Offer a terse response. 1.22. What is the ratio of the Revenue generated (in %) in Antigua and Barbuda in 2006 to that in 2009?
Your answer should be compact. 0.9. What is the ratio of the Revenue generated (in %) of Kenya in 2006 to that in 2009?
Give a very brief answer. 0.95. What is the ratio of the Revenue generated (in %) of Qatar in 2006 to that in 2009?
Offer a very short reply. 1.1. What is the ratio of the Revenue generated (in %) in South Africa in 2006 to that in 2009?
Give a very brief answer. 1.14. What is the ratio of the Revenue generated (in %) in Antigua and Barbuda in 2007 to that in 2008?
Provide a short and direct response. 1.05. What is the ratio of the Revenue generated (in %) of Kenya in 2007 to that in 2008?
Your answer should be compact. 0.96. What is the ratio of the Revenue generated (in %) in Qatar in 2007 to that in 2008?
Your answer should be compact. 1.06. What is the ratio of the Revenue generated (in %) in South Africa in 2007 to that in 2008?
Your answer should be very brief. 1.07. What is the ratio of the Revenue generated (in %) of Antigua and Barbuda in 2007 to that in 2009?
Provide a succinct answer. 0.87. What is the ratio of the Revenue generated (in %) in Kenya in 2007 to that in 2009?
Keep it short and to the point. 1.04. What is the ratio of the Revenue generated (in %) in Qatar in 2007 to that in 2009?
Provide a succinct answer. 0.74. What is the ratio of the Revenue generated (in %) of South Africa in 2007 to that in 2009?
Your answer should be compact. 1. What is the ratio of the Revenue generated (in %) in Antigua and Barbuda in 2008 to that in 2009?
Ensure brevity in your answer.  0.83. What is the ratio of the Revenue generated (in %) in Kenya in 2008 to that in 2009?
Provide a short and direct response. 1.08. What is the ratio of the Revenue generated (in %) in Qatar in 2008 to that in 2009?
Your response must be concise. 0.7. What is the ratio of the Revenue generated (in %) in South Africa in 2008 to that in 2009?
Make the answer very short. 0.93. What is the difference between the highest and the second highest Revenue generated (in %) of Antigua and Barbuda?
Provide a short and direct response. 4.91. What is the difference between the highest and the second highest Revenue generated (in %) of Kenya?
Your answer should be very brief. 0.41. What is the difference between the highest and the second highest Revenue generated (in %) of Qatar?
Your answer should be very brief. 0.53. What is the difference between the highest and the second highest Revenue generated (in %) of South Africa?
Provide a succinct answer. 1.47. What is the difference between the highest and the lowest Revenue generated (in %) in Antigua and Barbuda?
Provide a short and direct response. 12.54. What is the difference between the highest and the lowest Revenue generated (in %) in Kenya?
Your answer should be compact. 2.35. What is the difference between the highest and the lowest Revenue generated (in %) in Qatar?
Your response must be concise. 1.97. What is the difference between the highest and the lowest Revenue generated (in %) of South Africa?
Your answer should be very brief. 4.51. 